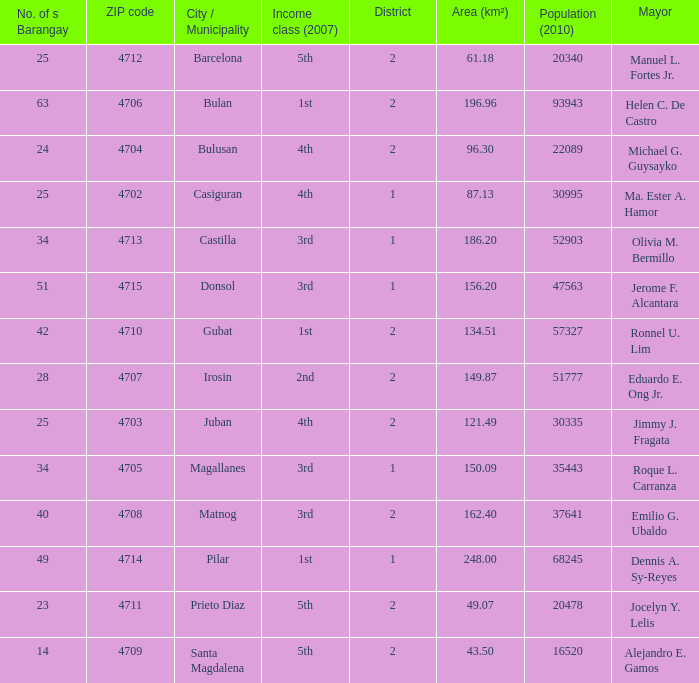What are all the vicinity (km²) where profits magnificence (2007) is 2nd 149.87. 